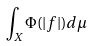Convert formula to latex. <formula><loc_0><loc_0><loc_500><loc_500>\int _ { X } \Phi ( | f | ) d \mu</formula> 